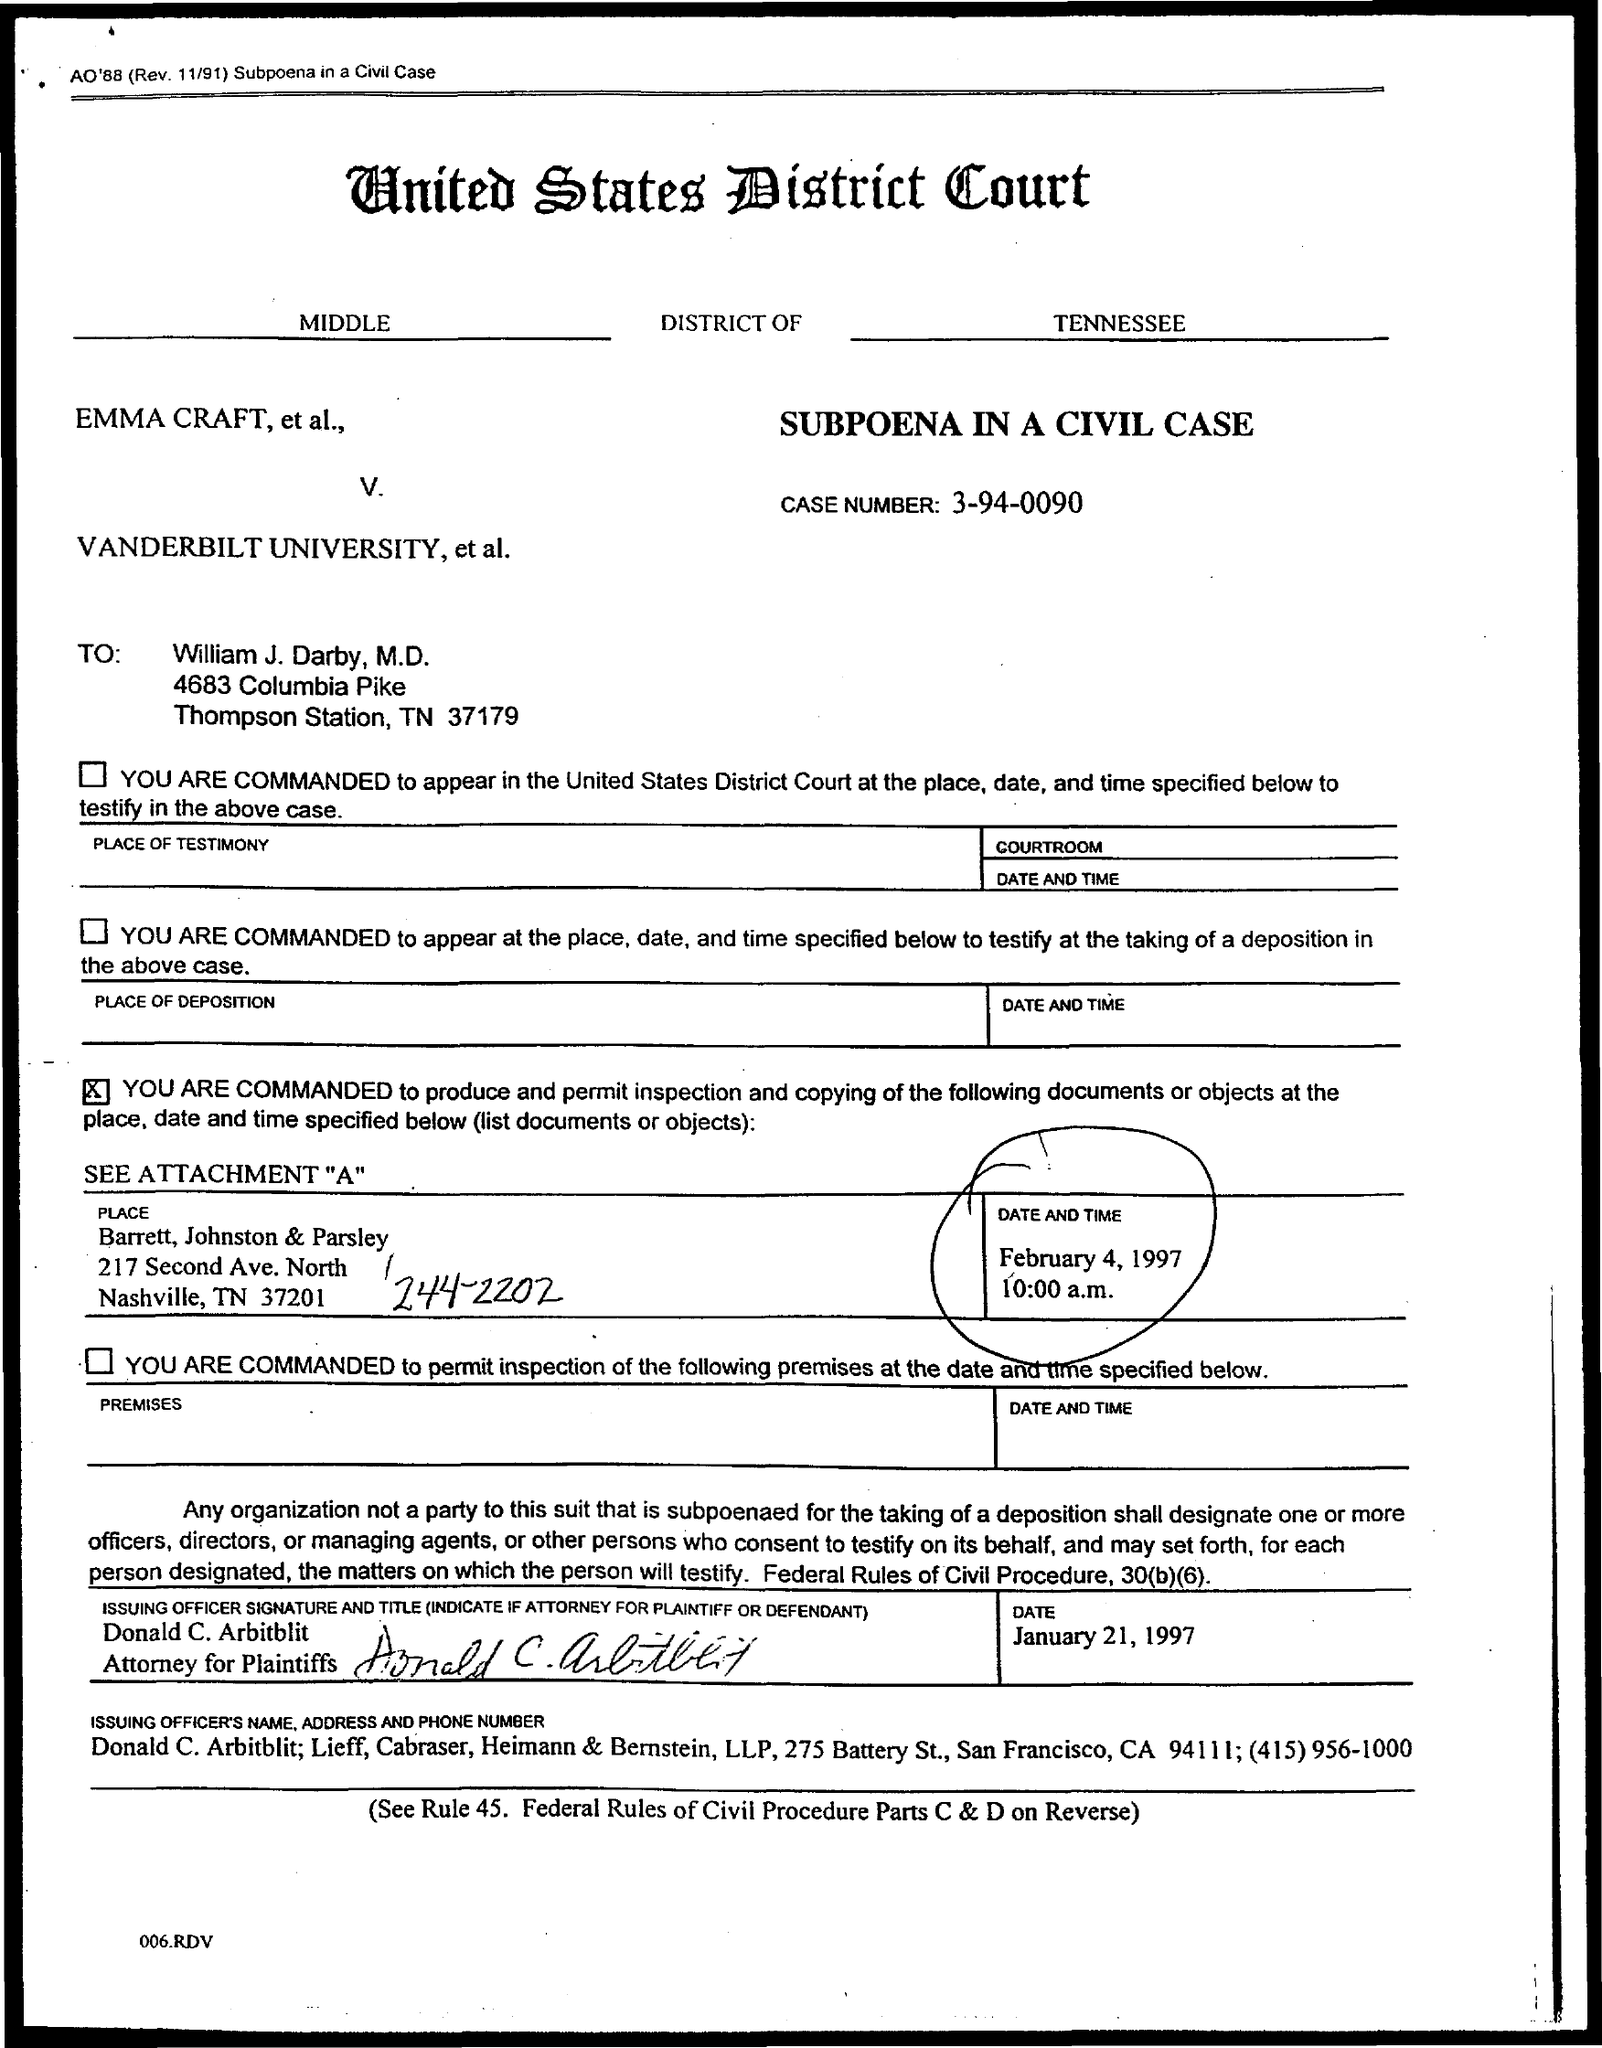Highlight a few significant elements in this photo. The document is addressed to William J. Darby, M.D. The United States District Court is the district court mentioned in this context. The case number given in the document is 3-94-0090. 